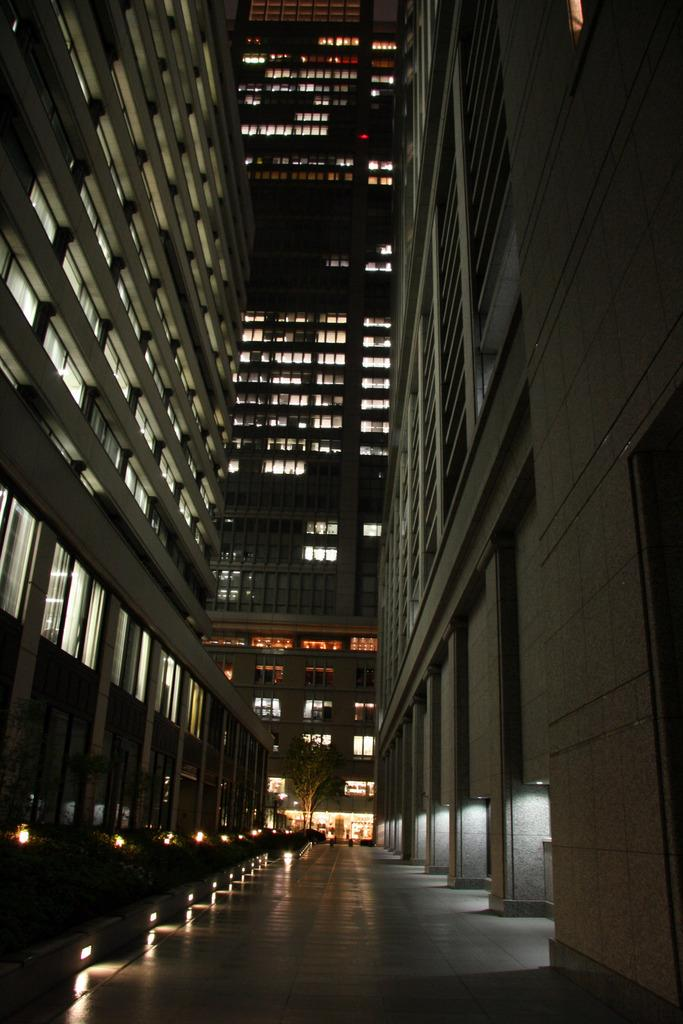What type of structure can be seen in the image? There are buildings in the image. What is the purpose of the path in the image? The path in the image provides a way for people to walk or travel between the buildings. What can be seen through the windows in the image? Windows are visible in the image, but it is not possible to determine what can be seen through them without more information. What type of illumination is present in the image? There are lights in the image, which may provide illumination for the buildings or path. What type of vegetation is present in the image? There is a tree in the image. Where is the poison located in the image? There is no poison present in the image. How many trees are visible in the image? The image only shows one tree, not multiple trees. 